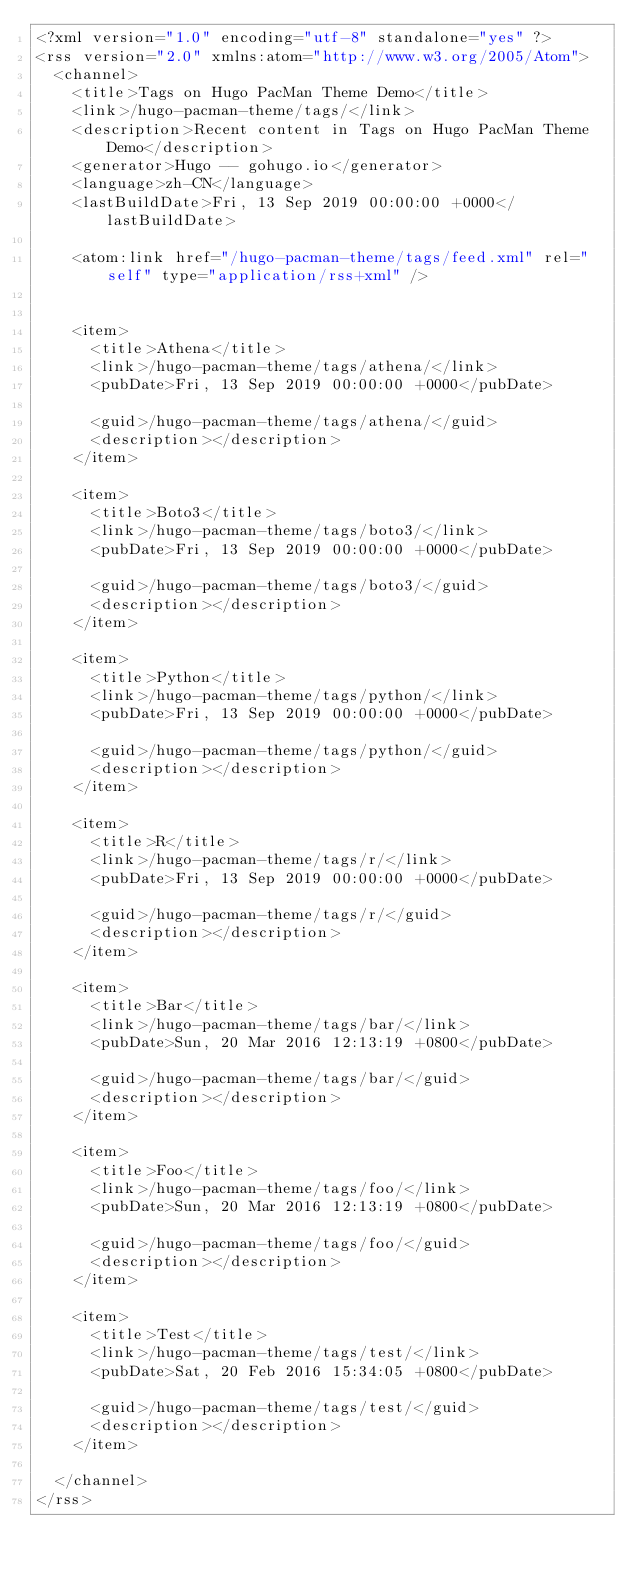<code> <loc_0><loc_0><loc_500><loc_500><_XML_><?xml version="1.0" encoding="utf-8" standalone="yes" ?>
<rss version="2.0" xmlns:atom="http://www.w3.org/2005/Atom">
  <channel>
    <title>Tags on Hugo PacMan Theme Demo</title>
    <link>/hugo-pacman-theme/tags/</link>
    <description>Recent content in Tags on Hugo PacMan Theme Demo</description>
    <generator>Hugo -- gohugo.io</generator>
    <language>zh-CN</language>
    <lastBuildDate>Fri, 13 Sep 2019 00:00:00 +0000</lastBuildDate>
    
	<atom:link href="/hugo-pacman-theme/tags/feed.xml" rel="self" type="application/rss+xml" />
    
    
    <item>
      <title>Athena</title>
      <link>/hugo-pacman-theme/tags/athena/</link>
      <pubDate>Fri, 13 Sep 2019 00:00:00 +0000</pubDate>
      
      <guid>/hugo-pacman-theme/tags/athena/</guid>
      <description></description>
    </item>
    
    <item>
      <title>Boto3</title>
      <link>/hugo-pacman-theme/tags/boto3/</link>
      <pubDate>Fri, 13 Sep 2019 00:00:00 +0000</pubDate>
      
      <guid>/hugo-pacman-theme/tags/boto3/</guid>
      <description></description>
    </item>
    
    <item>
      <title>Python</title>
      <link>/hugo-pacman-theme/tags/python/</link>
      <pubDate>Fri, 13 Sep 2019 00:00:00 +0000</pubDate>
      
      <guid>/hugo-pacman-theme/tags/python/</guid>
      <description></description>
    </item>
    
    <item>
      <title>R</title>
      <link>/hugo-pacman-theme/tags/r/</link>
      <pubDate>Fri, 13 Sep 2019 00:00:00 +0000</pubDate>
      
      <guid>/hugo-pacman-theme/tags/r/</guid>
      <description></description>
    </item>
    
    <item>
      <title>Bar</title>
      <link>/hugo-pacman-theme/tags/bar/</link>
      <pubDate>Sun, 20 Mar 2016 12:13:19 +0800</pubDate>
      
      <guid>/hugo-pacman-theme/tags/bar/</guid>
      <description></description>
    </item>
    
    <item>
      <title>Foo</title>
      <link>/hugo-pacman-theme/tags/foo/</link>
      <pubDate>Sun, 20 Mar 2016 12:13:19 +0800</pubDate>
      
      <guid>/hugo-pacman-theme/tags/foo/</guid>
      <description></description>
    </item>
    
    <item>
      <title>Test</title>
      <link>/hugo-pacman-theme/tags/test/</link>
      <pubDate>Sat, 20 Feb 2016 15:34:05 +0800</pubDate>
      
      <guid>/hugo-pacman-theme/tags/test/</guid>
      <description></description>
    </item>
    
  </channel>
</rss></code> 